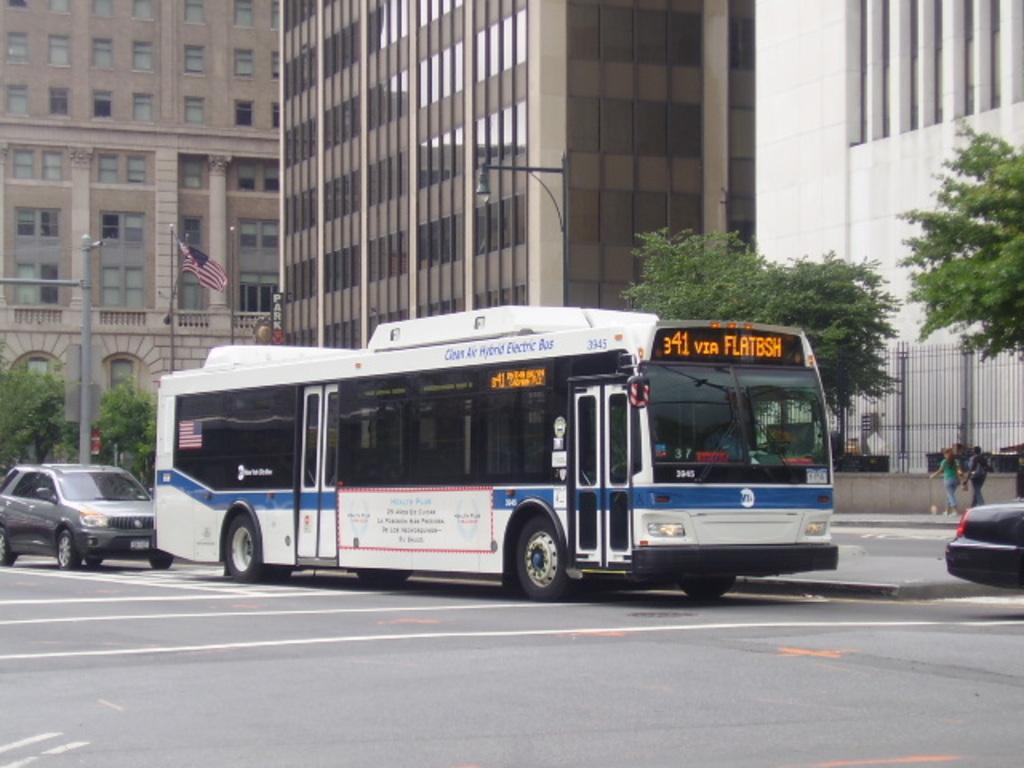Can you describe this image briefly? In the middle of the image there are some vehicles on the road. Behind the vehicles few people are walking and there is fencing and there are some trees and poles. At the top of the image there are some buildings. 